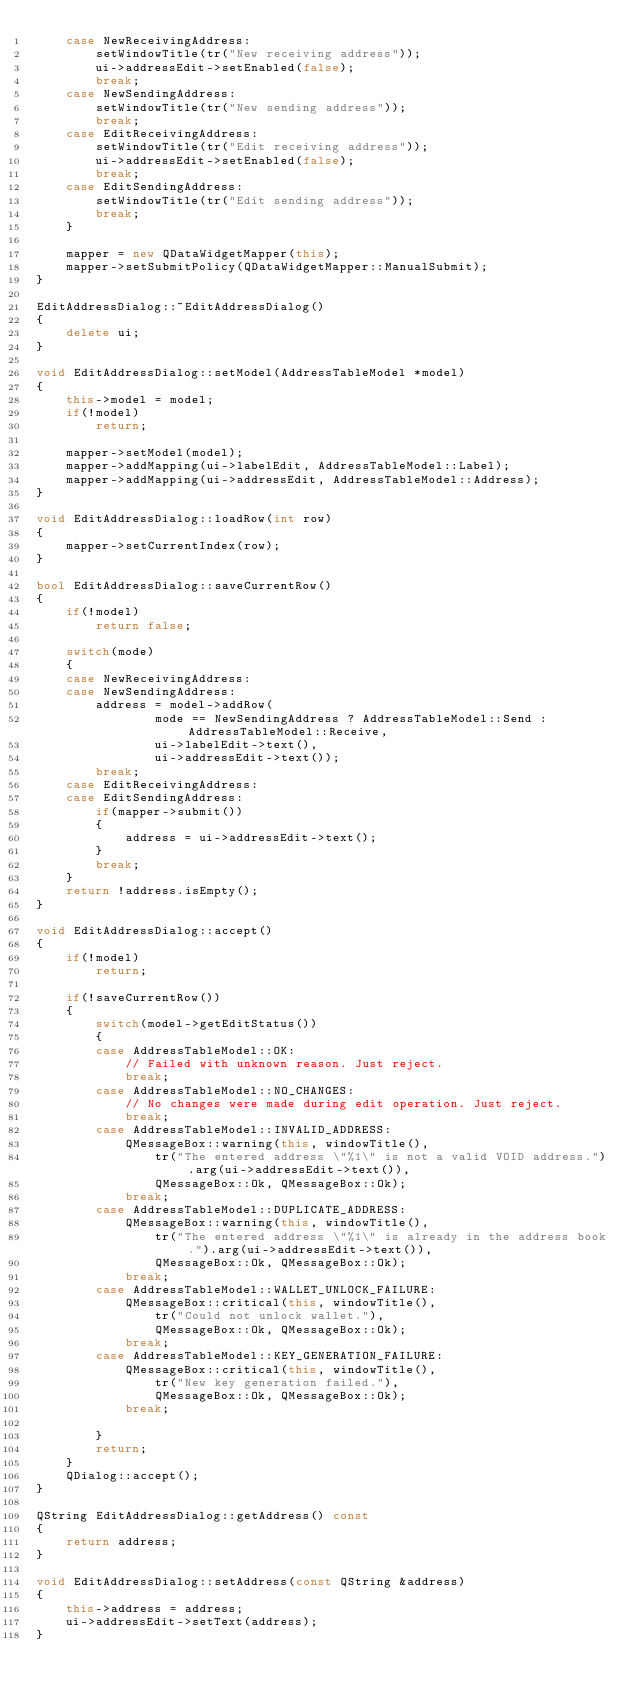<code> <loc_0><loc_0><loc_500><loc_500><_C++_>    case NewReceivingAddress:
        setWindowTitle(tr("New receiving address"));
        ui->addressEdit->setEnabled(false);
        break;
    case NewSendingAddress:
        setWindowTitle(tr("New sending address"));
        break;
    case EditReceivingAddress:
        setWindowTitle(tr("Edit receiving address"));
        ui->addressEdit->setEnabled(false);
        break;
    case EditSendingAddress:
        setWindowTitle(tr("Edit sending address"));
        break;
    }

    mapper = new QDataWidgetMapper(this);
    mapper->setSubmitPolicy(QDataWidgetMapper::ManualSubmit);
}

EditAddressDialog::~EditAddressDialog()
{
    delete ui;
}

void EditAddressDialog::setModel(AddressTableModel *model)
{
    this->model = model;
    if(!model)
        return;

    mapper->setModel(model);
    mapper->addMapping(ui->labelEdit, AddressTableModel::Label);
    mapper->addMapping(ui->addressEdit, AddressTableModel::Address);
}

void EditAddressDialog::loadRow(int row)
{
    mapper->setCurrentIndex(row);
}

bool EditAddressDialog::saveCurrentRow()
{
    if(!model)
        return false;

    switch(mode)
    {
    case NewReceivingAddress:
    case NewSendingAddress:
        address = model->addRow(
                mode == NewSendingAddress ? AddressTableModel::Send : AddressTableModel::Receive,
                ui->labelEdit->text(),
                ui->addressEdit->text());
        break;
    case EditReceivingAddress:
    case EditSendingAddress:
        if(mapper->submit())
        {
            address = ui->addressEdit->text();
        }
        break;
    }
    return !address.isEmpty();
}

void EditAddressDialog::accept()
{
    if(!model)
        return;

    if(!saveCurrentRow())
    {
        switch(model->getEditStatus())
        {
        case AddressTableModel::OK:
            // Failed with unknown reason. Just reject.
            break;
        case AddressTableModel::NO_CHANGES:
            // No changes were made during edit operation. Just reject.
            break;
        case AddressTableModel::INVALID_ADDRESS:
            QMessageBox::warning(this, windowTitle(),
                tr("The entered address \"%1\" is not a valid VOID address.").arg(ui->addressEdit->text()),
                QMessageBox::Ok, QMessageBox::Ok);
            break;
        case AddressTableModel::DUPLICATE_ADDRESS:
            QMessageBox::warning(this, windowTitle(),
                tr("The entered address \"%1\" is already in the address book.").arg(ui->addressEdit->text()),
                QMessageBox::Ok, QMessageBox::Ok);
            break;
        case AddressTableModel::WALLET_UNLOCK_FAILURE:
            QMessageBox::critical(this, windowTitle(),
                tr("Could not unlock wallet."),
                QMessageBox::Ok, QMessageBox::Ok);
            break;
        case AddressTableModel::KEY_GENERATION_FAILURE:
            QMessageBox::critical(this, windowTitle(),
                tr("New key generation failed."),
                QMessageBox::Ok, QMessageBox::Ok);
            break;

        }
        return;
    }
    QDialog::accept();
}

QString EditAddressDialog::getAddress() const
{
    return address;
}

void EditAddressDialog::setAddress(const QString &address)
{
    this->address = address;
    ui->addressEdit->setText(address);
}
</code> 